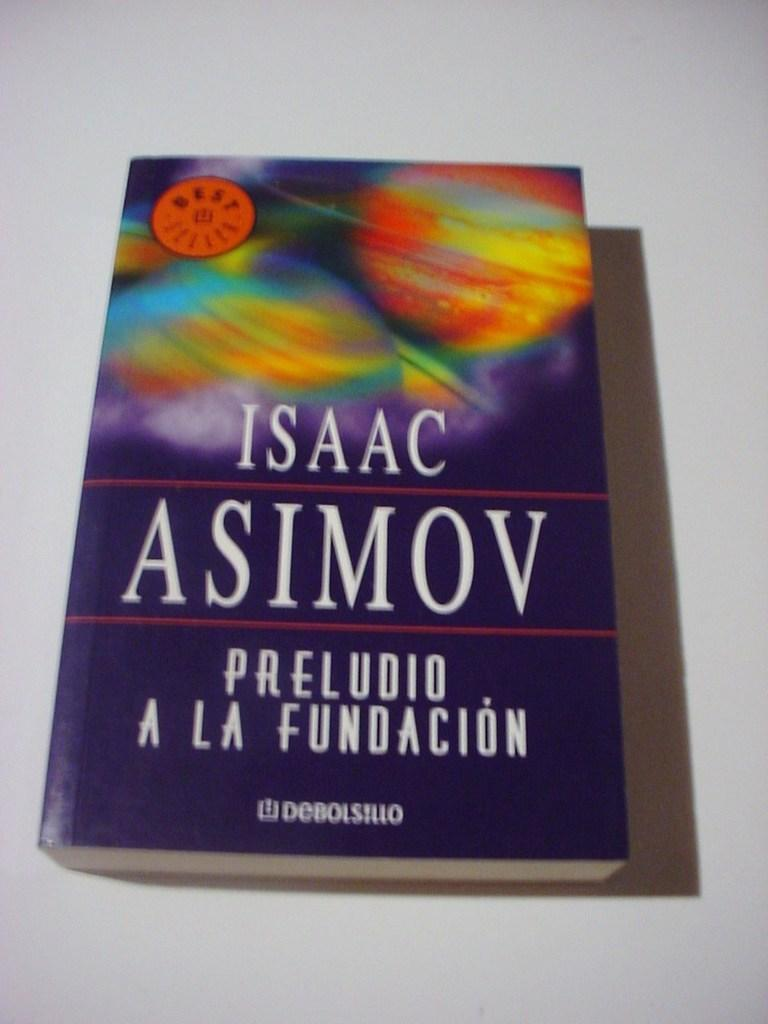<image>
Render a clear and concise summary of the photo. a book that is called 'preludio a la fundacion' by isaac asimov 